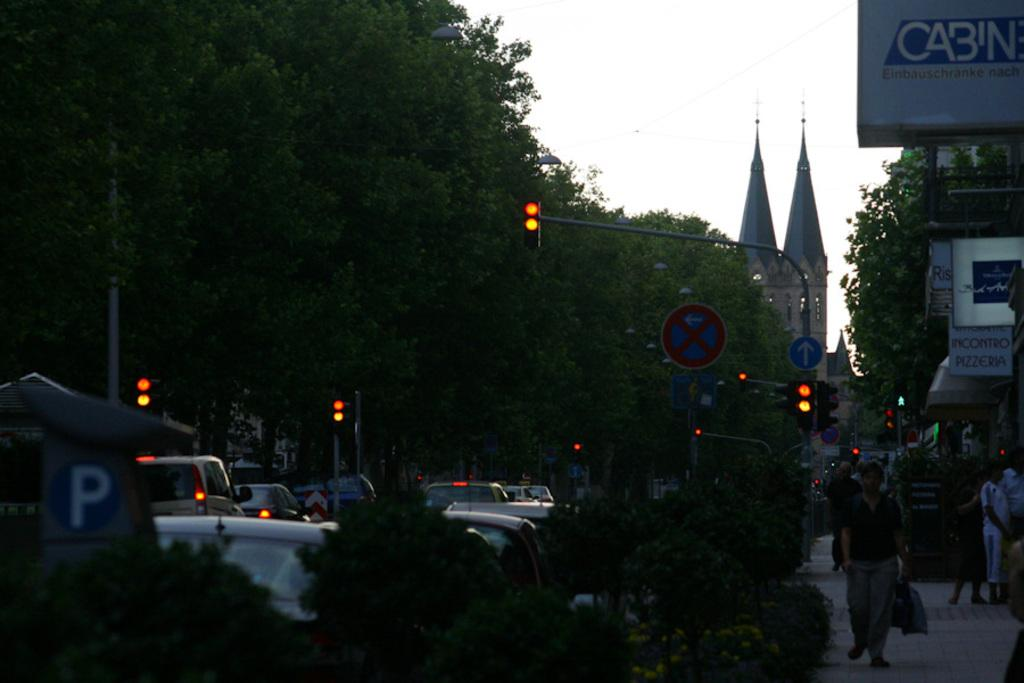What type of signals can be seen in the image? There are traffic signals in the image. What type of vegetation is present in the image? There are trees in the image. What type of vehicles can be seen in the image? There are cars in the image. Who or what is present in the image besides vehicles? There are people in the image. What type of structure can be seen in the image? There is at least one building in the image. What part of the natural environment is visible in the image? The sky is visible in the image. What type of signs are present in the image? There are name boards in the image. Can you tell me how many experts are attempting to fix the wheel in the image? There is no expert or wheel present in the image. What type of attempt is being made by the people in the image? The people in the image are not attempting anything specific related to a wheel or an expert; they are simply present in the scene. 